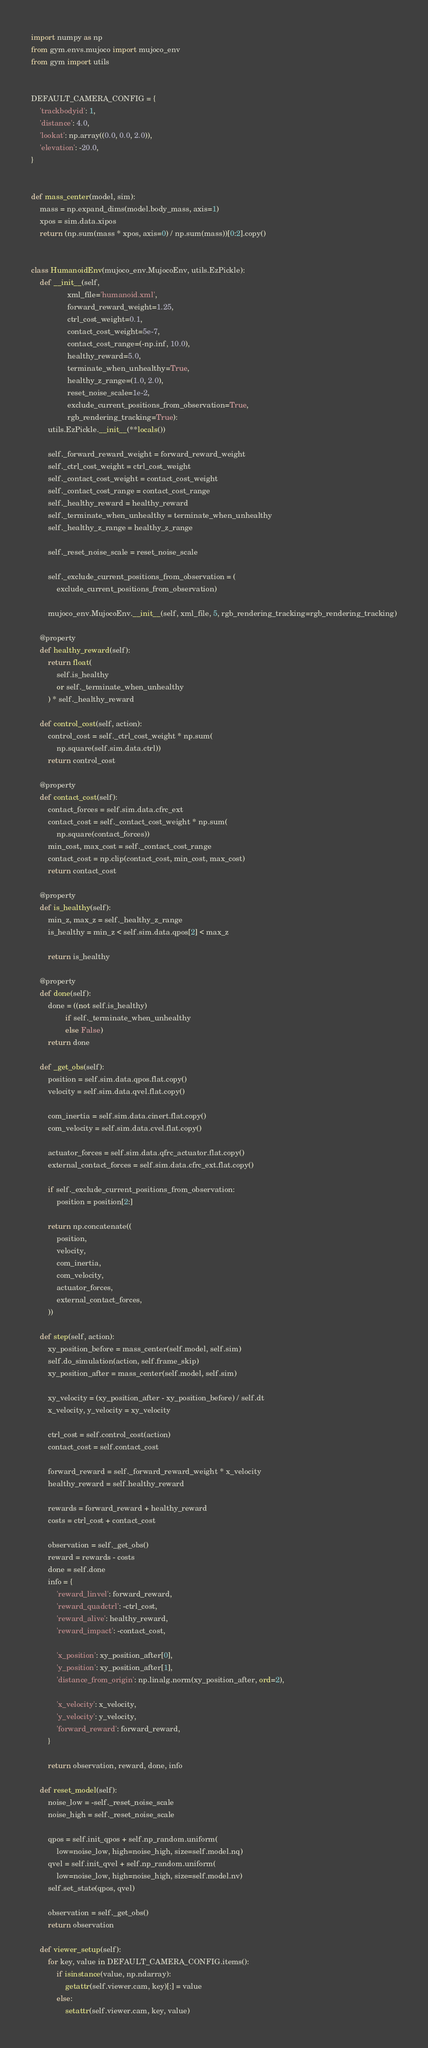<code> <loc_0><loc_0><loc_500><loc_500><_Python_>import numpy as np
from gym.envs.mujoco import mujoco_env
from gym import utils


DEFAULT_CAMERA_CONFIG = {
    'trackbodyid': 1,
    'distance': 4.0,
    'lookat': np.array((0.0, 0.0, 2.0)),
    'elevation': -20.0,
}


def mass_center(model, sim):
    mass = np.expand_dims(model.body_mass, axis=1)
    xpos = sim.data.xipos
    return (np.sum(mass * xpos, axis=0) / np.sum(mass))[0:2].copy()


class HumanoidEnv(mujoco_env.MujocoEnv, utils.EzPickle):
    def __init__(self,
                 xml_file='humanoid.xml',
                 forward_reward_weight=1.25,
                 ctrl_cost_weight=0.1,
                 contact_cost_weight=5e-7,
                 contact_cost_range=(-np.inf, 10.0),
                 healthy_reward=5.0,
                 terminate_when_unhealthy=True,
                 healthy_z_range=(1.0, 2.0),
                 reset_noise_scale=1e-2,
                 exclude_current_positions_from_observation=True,
                 rgb_rendering_tracking=True):
        utils.EzPickle.__init__(**locals())

        self._forward_reward_weight = forward_reward_weight
        self._ctrl_cost_weight = ctrl_cost_weight
        self._contact_cost_weight = contact_cost_weight
        self._contact_cost_range = contact_cost_range
        self._healthy_reward = healthy_reward
        self._terminate_when_unhealthy = terminate_when_unhealthy
        self._healthy_z_range = healthy_z_range

        self._reset_noise_scale = reset_noise_scale

        self._exclude_current_positions_from_observation = (
            exclude_current_positions_from_observation)

        mujoco_env.MujocoEnv.__init__(self, xml_file, 5, rgb_rendering_tracking=rgb_rendering_tracking)

    @property
    def healthy_reward(self):
        return float(
            self.is_healthy
            or self._terminate_when_unhealthy
        ) * self._healthy_reward

    def control_cost(self, action):
        control_cost = self._ctrl_cost_weight * np.sum(
            np.square(self.sim.data.ctrl))
        return control_cost

    @property
    def contact_cost(self):
        contact_forces = self.sim.data.cfrc_ext
        contact_cost = self._contact_cost_weight * np.sum(
            np.square(contact_forces))
        min_cost, max_cost = self._contact_cost_range
        contact_cost = np.clip(contact_cost, min_cost, max_cost)
        return contact_cost

    @property
    def is_healthy(self):
        min_z, max_z = self._healthy_z_range
        is_healthy = min_z < self.sim.data.qpos[2] < max_z

        return is_healthy

    @property
    def done(self):
        done = ((not self.is_healthy)
                if self._terminate_when_unhealthy
                else False)
        return done

    def _get_obs(self):
        position = self.sim.data.qpos.flat.copy()
        velocity = self.sim.data.qvel.flat.copy()

        com_inertia = self.sim.data.cinert.flat.copy()
        com_velocity = self.sim.data.cvel.flat.copy()

        actuator_forces = self.sim.data.qfrc_actuator.flat.copy()
        external_contact_forces = self.sim.data.cfrc_ext.flat.copy()

        if self._exclude_current_positions_from_observation:
            position = position[2:]

        return np.concatenate((
            position,
            velocity,
            com_inertia,
            com_velocity,
            actuator_forces,
            external_contact_forces,
        ))

    def step(self, action):
        xy_position_before = mass_center(self.model, self.sim)
        self.do_simulation(action, self.frame_skip)
        xy_position_after = mass_center(self.model, self.sim)

        xy_velocity = (xy_position_after - xy_position_before) / self.dt
        x_velocity, y_velocity = xy_velocity

        ctrl_cost = self.control_cost(action)
        contact_cost = self.contact_cost

        forward_reward = self._forward_reward_weight * x_velocity
        healthy_reward = self.healthy_reward

        rewards = forward_reward + healthy_reward
        costs = ctrl_cost + contact_cost

        observation = self._get_obs()
        reward = rewards - costs
        done = self.done
        info = {
            'reward_linvel': forward_reward,
            'reward_quadctrl': -ctrl_cost,
            'reward_alive': healthy_reward,
            'reward_impact': -contact_cost,

            'x_position': xy_position_after[0],
            'y_position': xy_position_after[1],
            'distance_from_origin': np.linalg.norm(xy_position_after, ord=2),

            'x_velocity': x_velocity,
            'y_velocity': y_velocity,
            'forward_reward': forward_reward,
        }

        return observation, reward, done, info

    def reset_model(self):
        noise_low = -self._reset_noise_scale
        noise_high = self._reset_noise_scale

        qpos = self.init_qpos + self.np_random.uniform(
            low=noise_low, high=noise_high, size=self.model.nq)
        qvel = self.init_qvel + self.np_random.uniform(
            low=noise_low, high=noise_high, size=self.model.nv)
        self.set_state(qpos, qvel)

        observation = self._get_obs()
        return observation

    def viewer_setup(self):
        for key, value in DEFAULT_CAMERA_CONFIG.items():
            if isinstance(value, np.ndarray):
                getattr(self.viewer.cam, key)[:] = value
            else:
                setattr(self.viewer.cam, key, value)
</code> 